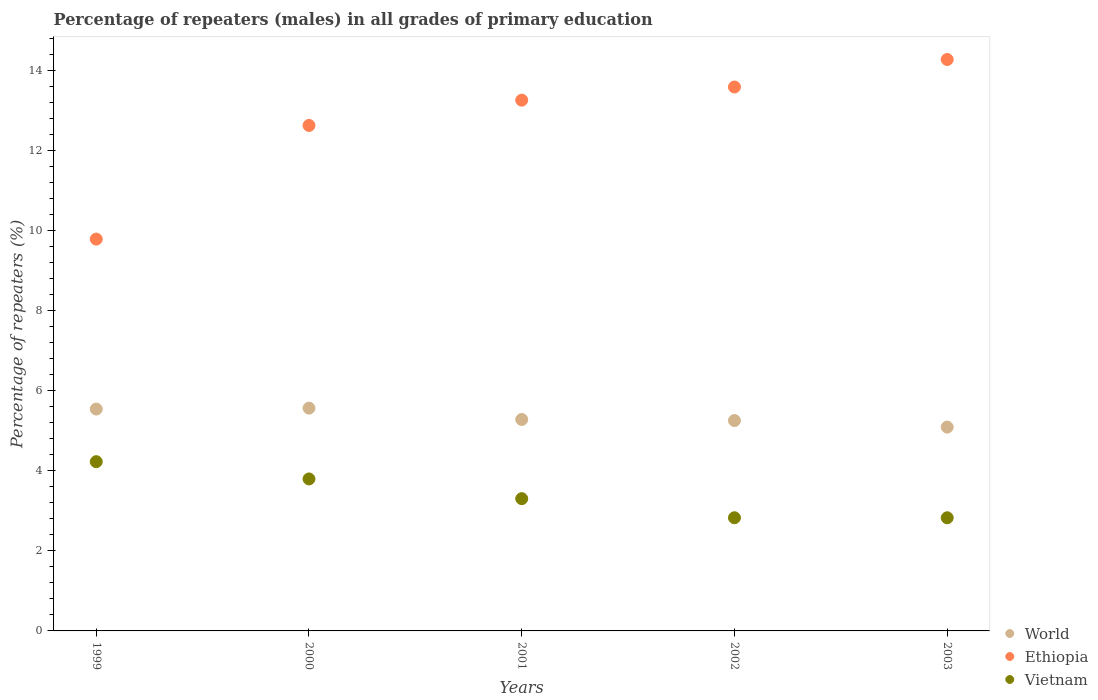How many different coloured dotlines are there?
Your response must be concise. 3. What is the percentage of repeaters (males) in World in 1999?
Keep it short and to the point. 5.54. Across all years, what is the maximum percentage of repeaters (males) in World?
Provide a short and direct response. 5.57. Across all years, what is the minimum percentage of repeaters (males) in Ethiopia?
Make the answer very short. 9.79. What is the total percentage of repeaters (males) in Ethiopia in the graph?
Your answer should be compact. 63.54. What is the difference between the percentage of repeaters (males) in Ethiopia in 2001 and that in 2003?
Keep it short and to the point. -1.02. What is the difference between the percentage of repeaters (males) in World in 2002 and the percentage of repeaters (males) in Ethiopia in 1999?
Make the answer very short. -4.53. What is the average percentage of repeaters (males) in Ethiopia per year?
Keep it short and to the point. 12.71. In the year 2001, what is the difference between the percentage of repeaters (males) in Vietnam and percentage of repeaters (males) in Ethiopia?
Provide a short and direct response. -9.96. What is the ratio of the percentage of repeaters (males) in Vietnam in 2000 to that in 2002?
Provide a short and direct response. 1.34. Is the percentage of repeaters (males) in World in 1999 less than that in 2000?
Your answer should be compact. Yes. What is the difference between the highest and the second highest percentage of repeaters (males) in World?
Your answer should be very brief. 0.02. What is the difference between the highest and the lowest percentage of repeaters (males) in Vietnam?
Make the answer very short. 1.4. In how many years, is the percentage of repeaters (males) in Ethiopia greater than the average percentage of repeaters (males) in Ethiopia taken over all years?
Provide a succinct answer. 3. Is it the case that in every year, the sum of the percentage of repeaters (males) in World and percentage of repeaters (males) in Vietnam  is greater than the percentage of repeaters (males) in Ethiopia?
Make the answer very short. No. Is the percentage of repeaters (males) in Vietnam strictly less than the percentage of repeaters (males) in Ethiopia over the years?
Keep it short and to the point. Yes. What is the difference between two consecutive major ticks on the Y-axis?
Offer a terse response. 2. Are the values on the major ticks of Y-axis written in scientific E-notation?
Ensure brevity in your answer.  No. Does the graph contain grids?
Keep it short and to the point. No. What is the title of the graph?
Your answer should be very brief. Percentage of repeaters (males) in all grades of primary education. Does "Arab World" appear as one of the legend labels in the graph?
Offer a terse response. No. What is the label or title of the Y-axis?
Your response must be concise. Percentage of repeaters (%). What is the Percentage of repeaters (%) of World in 1999?
Provide a succinct answer. 5.54. What is the Percentage of repeaters (%) in Ethiopia in 1999?
Give a very brief answer. 9.79. What is the Percentage of repeaters (%) of Vietnam in 1999?
Provide a short and direct response. 4.23. What is the Percentage of repeaters (%) in World in 2000?
Your answer should be compact. 5.57. What is the Percentage of repeaters (%) of Ethiopia in 2000?
Your answer should be very brief. 12.63. What is the Percentage of repeaters (%) in Vietnam in 2000?
Make the answer very short. 3.8. What is the Percentage of repeaters (%) in World in 2001?
Keep it short and to the point. 5.28. What is the Percentage of repeaters (%) of Ethiopia in 2001?
Provide a succinct answer. 13.26. What is the Percentage of repeaters (%) of Vietnam in 2001?
Provide a succinct answer. 3.3. What is the Percentage of repeaters (%) of World in 2002?
Offer a very short reply. 5.26. What is the Percentage of repeaters (%) of Ethiopia in 2002?
Your answer should be compact. 13.59. What is the Percentage of repeaters (%) of Vietnam in 2002?
Offer a very short reply. 2.83. What is the Percentage of repeaters (%) of World in 2003?
Provide a short and direct response. 5.09. What is the Percentage of repeaters (%) in Ethiopia in 2003?
Your answer should be very brief. 14.28. What is the Percentage of repeaters (%) in Vietnam in 2003?
Make the answer very short. 2.83. Across all years, what is the maximum Percentage of repeaters (%) of World?
Make the answer very short. 5.57. Across all years, what is the maximum Percentage of repeaters (%) of Ethiopia?
Offer a very short reply. 14.28. Across all years, what is the maximum Percentage of repeaters (%) of Vietnam?
Give a very brief answer. 4.23. Across all years, what is the minimum Percentage of repeaters (%) in World?
Provide a succinct answer. 5.09. Across all years, what is the minimum Percentage of repeaters (%) in Ethiopia?
Keep it short and to the point. 9.79. Across all years, what is the minimum Percentage of repeaters (%) of Vietnam?
Provide a succinct answer. 2.83. What is the total Percentage of repeaters (%) of World in the graph?
Your response must be concise. 26.74. What is the total Percentage of repeaters (%) of Ethiopia in the graph?
Provide a succinct answer. 63.54. What is the total Percentage of repeaters (%) of Vietnam in the graph?
Provide a short and direct response. 16.98. What is the difference between the Percentage of repeaters (%) of World in 1999 and that in 2000?
Your answer should be compact. -0.02. What is the difference between the Percentage of repeaters (%) in Ethiopia in 1999 and that in 2000?
Offer a terse response. -2.84. What is the difference between the Percentage of repeaters (%) of Vietnam in 1999 and that in 2000?
Your response must be concise. 0.43. What is the difference between the Percentage of repeaters (%) of World in 1999 and that in 2001?
Offer a very short reply. 0.26. What is the difference between the Percentage of repeaters (%) in Ethiopia in 1999 and that in 2001?
Your answer should be compact. -3.47. What is the difference between the Percentage of repeaters (%) in Vietnam in 1999 and that in 2001?
Provide a short and direct response. 0.92. What is the difference between the Percentage of repeaters (%) in World in 1999 and that in 2002?
Ensure brevity in your answer.  0.29. What is the difference between the Percentage of repeaters (%) in Ethiopia in 1999 and that in 2002?
Your answer should be very brief. -3.8. What is the difference between the Percentage of repeaters (%) of Vietnam in 1999 and that in 2002?
Offer a very short reply. 1.4. What is the difference between the Percentage of repeaters (%) of World in 1999 and that in 2003?
Your answer should be compact. 0.45. What is the difference between the Percentage of repeaters (%) in Ethiopia in 1999 and that in 2003?
Offer a very short reply. -4.49. What is the difference between the Percentage of repeaters (%) of Vietnam in 1999 and that in 2003?
Provide a short and direct response. 1.4. What is the difference between the Percentage of repeaters (%) in World in 2000 and that in 2001?
Make the answer very short. 0.28. What is the difference between the Percentage of repeaters (%) of Ethiopia in 2000 and that in 2001?
Ensure brevity in your answer.  -0.63. What is the difference between the Percentage of repeaters (%) of Vietnam in 2000 and that in 2001?
Provide a short and direct response. 0.49. What is the difference between the Percentage of repeaters (%) in World in 2000 and that in 2002?
Offer a terse response. 0.31. What is the difference between the Percentage of repeaters (%) in Ethiopia in 2000 and that in 2002?
Provide a succinct answer. -0.96. What is the difference between the Percentage of repeaters (%) of Vietnam in 2000 and that in 2002?
Offer a very short reply. 0.97. What is the difference between the Percentage of repeaters (%) in World in 2000 and that in 2003?
Your answer should be compact. 0.47. What is the difference between the Percentage of repeaters (%) in Ethiopia in 2000 and that in 2003?
Offer a very short reply. -1.65. What is the difference between the Percentage of repeaters (%) of Vietnam in 2000 and that in 2003?
Provide a short and direct response. 0.97. What is the difference between the Percentage of repeaters (%) in World in 2001 and that in 2002?
Provide a short and direct response. 0.03. What is the difference between the Percentage of repeaters (%) in Ethiopia in 2001 and that in 2002?
Make the answer very short. -0.33. What is the difference between the Percentage of repeaters (%) in Vietnam in 2001 and that in 2002?
Provide a short and direct response. 0.48. What is the difference between the Percentage of repeaters (%) in World in 2001 and that in 2003?
Keep it short and to the point. 0.19. What is the difference between the Percentage of repeaters (%) of Ethiopia in 2001 and that in 2003?
Your answer should be compact. -1.02. What is the difference between the Percentage of repeaters (%) of Vietnam in 2001 and that in 2003?
Ensure brevity in your answer.  0.48. What is the difference between the Percentage of repeaters (%) of World in 2002 and that in 2003?
Your answer should be compact. 0.16. What is the difference between the Percentage of repeaters (%) of Ethiopia in 2002 and that in 2003?
Ensure brevity in your answer.  -0.69. What is the difference between the Percentage of repeaters (%) of World in 1999 and the Percentage of repeaters (%) of Ethiopia in 2000?
Ensure brevity in your answer.  -7.08. What is the difference between the Percentage of repeaters (%) of World in 1999 and the Percentage of repeaters (%) of Vietnam in 2000?
Give a very brief answer. 1.75. What is the difference between the Percentage of repeaters (%) of Ethiopia in 1999 and the Percentage of repeaters (%) of Vietnam in 2000?
Your answer should be compact. 5.99. What is the difference between the Percentage of repeaters (%) in World in 1999 and the Percentage of repeaters (%) in Ethiopia in 2001?
Offer a terse response. -7.72. What is the difference between the Percentage of repeaters (%) in World in 1999 and the Percentage of repeaters (%) in Vietnam in 2001?
Offer a terse response. 2.24. What is the difference between the Percentage of repeaters (%) of Ethiopia in 1999 and the Percentage of repeaters (%) of Vietnam in 2001?
Your response must be concise. 6.48. What is the difference between the Percentage of repeaters (%) of World in 1999 and the Percentage of repeaters (%) of Ethiopia in 2002?
Make the answer very short. -8.05. What is the difference between the Percentage of repeaters (%) in World in 1999 and the Percentage of repeaters (%) in Vietnam in 2002?
Make the answer very short. 2.72. What is the difference between the Percentage of repeaters (%) of Ethiopia in 1999 and the Percentage of repeaters (%) of Vietnam in 2002?
Provide a short and direct response. 6.96. What is the difference between the Percentage of repeaters (%) in World in 1999 and the Percentage of repeaters (%) in Ethiopia in 2003?
Your response must be concise. -8.73. What is the difference between the Percentage of repeaters (%) of World in 1999 and the Percentage of repeaters (%) of Vietnam in 2003?
Provide a succinct answer. 2.72. What is the difference between the Percentage of repeaters (%) in Ethiopia in 1999 and the Percentage of repeaters (%) in Vietnam in 2003?
Keep it short and to the point. 6.96. What is the difference between the Percentage of repeaters (%) of World in 2000 and the Percentage of repeaters (%) of Ethiopia in 2001?
Ensure brevity in your answer.  -7.69. What is the difference between the Percentage of repeaters (%) in World in 2000 and the Percentage of repeaters (%) in Vietnam in 2001?
Give a very brief answer. 2.26. What is the difference between the Percentage of repeaters (%) in Ethiopia in 2000 and the Percentage of repeaters (%) in Vietnam in 2001?
Provide a short and direct response. 9.32. What is the difference between the Percentage of repeaters (%) in World in 2000 and the Percentage of repeaters (%) in Ethiopia in 2002?
Offer a terse response. -8.02. What is the difference between the Percentage of repeaters (%) in World in 2000 and the Percentage of repeaters (%) in Vietnam in 2002?
Make the answer very short. 2.74. What is the difference between the Percentage of repeaters (%) of Ethiopia in 2000 and the Percentage of repeaters (%) of Vietnam in 2002?
Ensure brevity in your answer.  9.8. What is the difference between the Percentage of repeaters (%) of World in 2000 and the Percentage of repeaters (%) of Ethiopia in 2003?
Give a very brief answer. -8.71. What is the difference between the Percentage of repeaters (%) in World in 2000 and the Percentage of repeaters (%) in Vietnam in 2003?
Offer a very short reply. 2.74. What is the difference between the Percentage of repeaters (%) in Ethiopia in 2000 and the Percentage of repeaters (%) in Vietnam in 2003?
Your answer should be compact. 9.8. What is the difference between the Percentage of repeaters (%) of World in 2001 and the Percentage of repeaters (%) of Ethiopia in 2002?
Provide a short and direct response. -8.31. What is the difference between the Percentage of repeaters (%) in World in 2001 and the Percentage of repeaters (%) in Vietnam in 2002?
Offer a terse response. 2.46. What is the difference between the Percentage of repeaters (%) of Ethiopia in 2001 and the Percentage of repeaters (%) of Vietnam in 2002?
Your response must be concise. 10.43. What is the difference between the Percentage of repeaters (%) of World in 2001 and the Percentage of repeaters (%) of Ethiopia in 2003?
Give a very brief answer. -8.99. What is the difference between the Percentage of repeaters (%) in World in 2001 and the Percentage of repeaters (%) in Vietnam in 2003?
Offer a very short reply. 2.46. What is the difference between the Percentage of repeaters (%) of Ethiopia in 2001 and the Percentage of repeaters (%) of Vietnam in 2003?
Make the answer very short. 10.43. What is the difference between the Percentage of repeaters (%) in World in 2002 and the Percentage of repeaters (%) in Ethiopia in 2003?
Your response must be concise. -9.02. What is the difference between the Percentage of repeaters (%) in World in 2002 and the Percentage of repeaters (%) in Vietnam in 2003?
Offer a very short reply. 2.43. What is the difference between the Percentage of repeaters (%) in Ethiopia in 2002 and the Percentage of repeaters (%) in Vietnam in 2003?
Your response must be concise. 10.76. What is the average Percentage of repeaters (%) in World per year?
Give a very brief answer. 5.35. What is the average Percentage of repeaters (%) of Ethiopia per year?
Give a very brief answer. 12.71. What is the average Percentage of repeaters (%) in Vietnam per year?
Give a very brief answer. 3.4. In the year 1999, what is the difference between the Percentage of repeaters (%) of World and Percentage of repeaters (%) of Ethiopia?
Offer a terse response. -4.25. In the year 1999, what is the difference between the Percentage of repeaters (%) of World and Percentage of repeaters (%) of Vietnam?
Offer a terse response. 1.31. In the year 1999, what is the difference between the Percentage of repeaters (%) of Ethiopia and Percentage of repeaters (%) of Vietnam?
Make the answer very short. 5.56. In the year 2000, what is the difference between the Percentage of repeaters (%) in World and Percentage of repeaters (%) in Ethiopia?
Your answer should be very brief. -7.06. In the year 2000, what is the difference between the Percentage of repeaters (%) in World and Percentage of repeaters (%) in Vietnam?
Your answer should be very brief. 1.77. In the year 2000, what is the difference between the Percentage of repeaters (%) in Ethiopia and Percentage of repeaters (%) in Vietnam?
Your answer should be compact. 8.83. In the year 2001, what is the difference between the Percentage of repeaters (%) of World and Percentage of repeaters (%) of Ethiopia?
Ensure brevity in your answer.  -7.98. In the year 2001, what is the difference between the Percentage of repeaters (%) in World and Percentage of repeaters (%) in Vietnam?
Offer a terse response. 1.98. In the year 2001, what is the difference between the Percentage of repeaters (%) of Ethiopia and Percentage of repeaters (%) of Vietnam?
Provide a short and direct response. 9.96. In the year 2002, what is the difference between the Percentage of repeaters (%) of World and Percentage of repeaters (%) of Ethiopia?
Offer a terse response. -8.33. In the year 2002, what is the difference between the Percentage of repeaters (%) in World and Percentage of repeaters (%) in Vietnam?
Offer a terse response. 2.43. In the year 2002, what is the difference between the Percentage of repeaters (%) in Ethiopia and Percentage of repeaters (%) in Vietnam?
Offer a terse response. 10.76. In the year 2003, what is the difference between the Percentage of repeaters (%) in World and Percentage of repeaters (%) in Ethiopia?
Offer a terse response. -9.18. In the year 2003, what is the difference between the Percentage of repeaters (%) of World and Percentage of repeaters (%) of Vietnam?
Offer a terse response. 2.27. In the year 2003, what is the difference between the Percentage of repeaters (%) in Ethiopia and Percentage of repeaters (%) in Vietnam?
Your answer should be very brief. 11.45. What is the ratio of the Percentage of repeaters (%) in World in 1999 to that in 2000?
Ensure brevity in your answer.  1. What is the ratio of the Percentage of repeaters (%) of Ethiopia in 1999 to that in 2000?
Keep it short and to the point. 0.78. What is the ratio of the Percentage of repeaters (%) in Vietnam in 1999 to that in 2000?
Your answer should be very brief. 1.11. What is the ratio of the Percentage of repeaters (%) in World in 1999 to that in 2001?
Give a very brief answer. 1.05. What is the ratio of the Percentage of repeaters (%) of Ethiopia in 1999 to that in 2001?
Provide a short and direct response. 0.74. What is the ratio of the Percentage of repeaters (%) in Vietnam in 1999 to that in 2001?
Offer a terse response. 1.28. What is the ratio of the Percentage of repeaters (%) of World in 1999 to that in 2002?
Offer a very short reply. 1.05. What is the ratio of the Percentage of repeaters (%) of Ethiopia in 1999 to that in 2002?
Give a very brief answer. 0.72. What is the ratio of the Percentage of repeaters (%) in Vietnam in 1999 to that in 2002?
Give a very brief answer. 1.5. What is the ratio of the Percentage of repeaters (%) in World in 1999 to that in 2003?
Your answer should be compact. 1.09. What is the ratio of the Percentage of repeaters (%) in Ethiopia in 1999 to that in 2003?
Ensure brevity in your answer.  0.69. What is the ratio of the Percentage of repeaters (%) of Vietnam in 1999 to that in 2003?
Provide a succinct answer. 1.5. What is the ratio of the Percentage of repeaters (%) of World in 2000 to that in 2001?
Your answer should be compact. 1.05. What is the ratio of the Percentage of repeaters (%) in Ethiopia in 2000 to that in 2001?
Keep it short and to the point. 0.95. What is the ratio of the Percentage of repeaters (%) in Vietnam in 2000 to that in 2001?
Offer a terse response. 1.15. What is the ratio of the Percentage of repeaters (%) in World in 2000 to that in 2002?
Give a very brief answer. 1.06. What is the ratio of the Percentage of repeaters (%) in Ethiopia in 2000 to that in 2002?
Provide a short and direct response. 0.93. What is the ratio of the Percentage of repeaters (%) of Vietnam in 2000 to that in 2002?
Ensure brevity in your answer.  1.34. What is the ratio of the Percentage of repeaters (%) in World in 2000 to that in 2003?
Provide a succinct answer. 1.09. What is the ratio of the Percentage of repeaters (%) in Ethiopia in 2000 to that in 2003?
Provide a succinct answer. 0.88. What is the ratio of the Percentage of repeaters (%) in Vietnam in 2000 to that in 2003?
Keep it short and to the point. 1.34. What is the ratio of the Percentage of repeaters (%) in Ethiopia in 2001 to that in 2002?
Provide a succinct answer. 0.98. What is the ratio of the Percentage of repeaters (%) in Vietnam in 2001 to that in 2002?
Offer a very short reply. 1.17. What is the ratio of the Percentage of repeaters (%) of World in 2001 to that in 2003?
Your answer should be very brief. 1.04. What is the ratio of the Percentage of repeaters (%) of Ethiopia in 2001 to that in 2003?
Offer a terse response. 0.93. What is the ratio of the Percentage of repeaters (%) in Vietnam in 2001 to that in 2003?
Your answer should be very brief. 1.17. What is the ratio of the Percentage of repeaters (%) in World in 2002 to that in 2003?
Keep it short and to the point. 1.03. What is the ratio of the Percentage of repeaters (%) of Ethiopia in 2002 to that in 2003?
Give a very brief answer. 0.95. What is the difference between the highest and the second highest Percentage of repeaters (%) in World?
Provide a short and direct response. 0.02. What is the difference between the highest and the second highest Percentage of repeaters (%) in Ethiopia?
Your response must be concise. 0.69. What is the difference between the highest and the second highest Percentage of repeaters (%) in Vietnam?
Ensure brevity in your answer.  0.43. What is the difference between the highest and the lowest Percentage of repeaters (%) in World?
Offer a very short reply. 0.47. What is the difference between the highest and the lowest Percentage of repeaters (%) of Ethiopia?
Ensure brevity in your answer.  4.49. What is the difference between the highest and the lowest Percentage of repeaters (%) in Vietnam?
Make the answer very short. 1.4. 